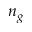<formula> <loc_0><loc_0><loc_500><loc_500>n _ { g }</formula> 